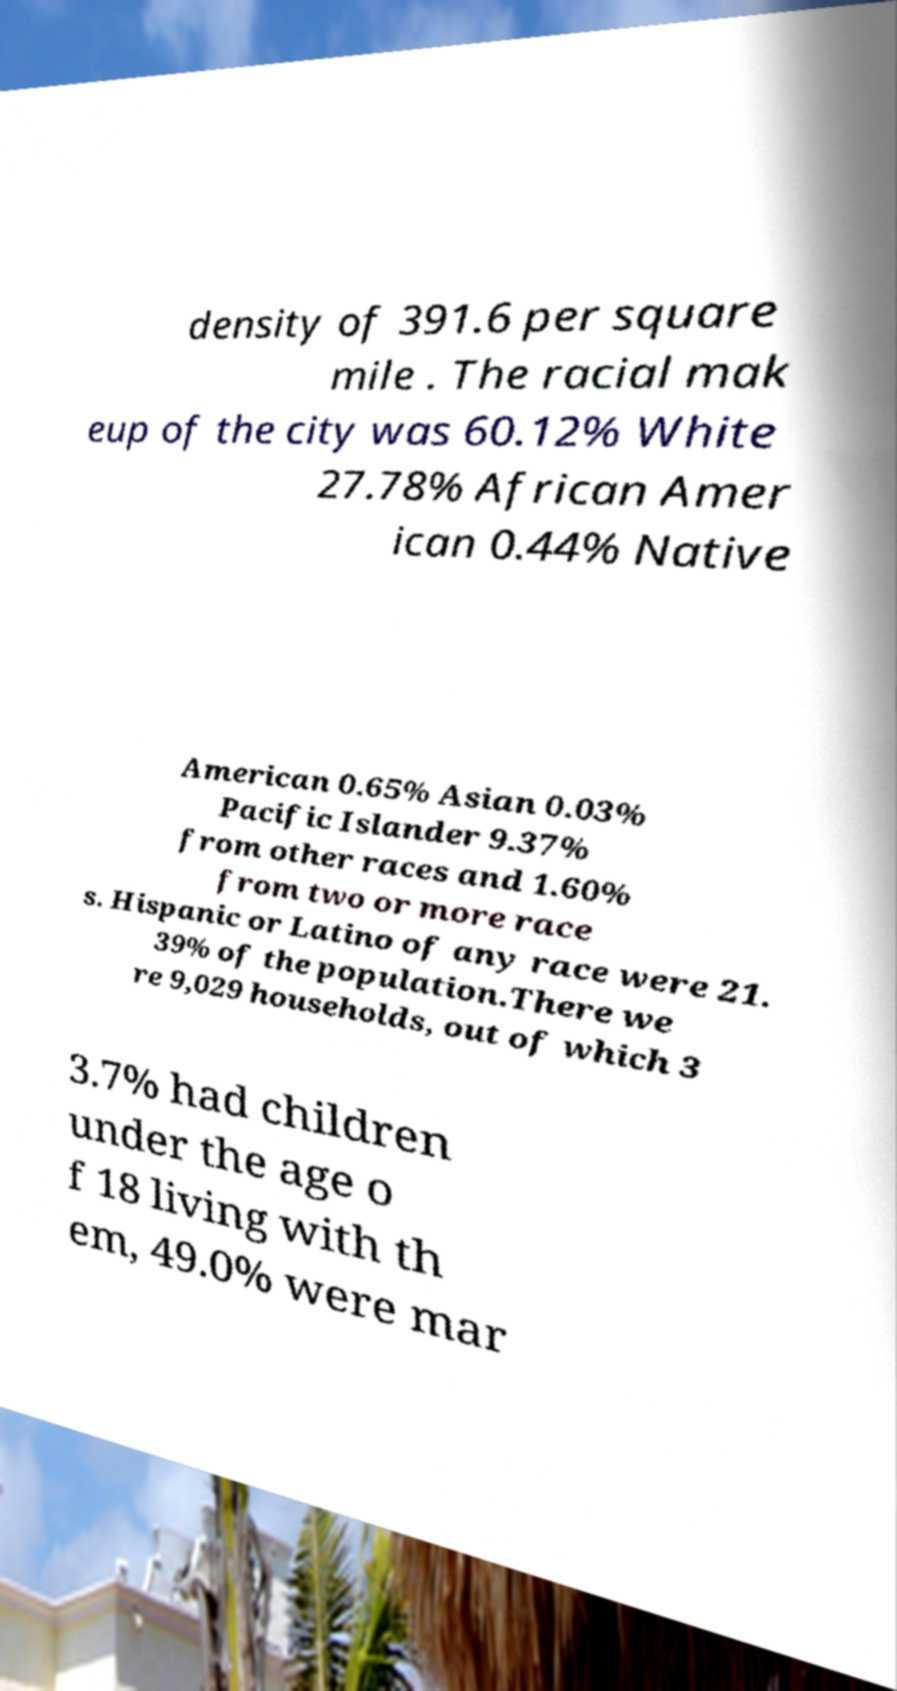For documentation purposes, I need the text within this image transcribed. Could you provide that? density of 391.6 per square mile . The racial mak eup of the city was 60.12% White 27.78% African Amer ican 0.44% Native American 0.65% Asian 0.03% Pacific Islander 9.37% from other races and 1.60% from two or more race s. Hispanic or Latino of any race were 21. 39% of the population.There we re 9,029 households, out of which 3 3.7% had children under the age o f 18 living with th em, 49.0% were mar 